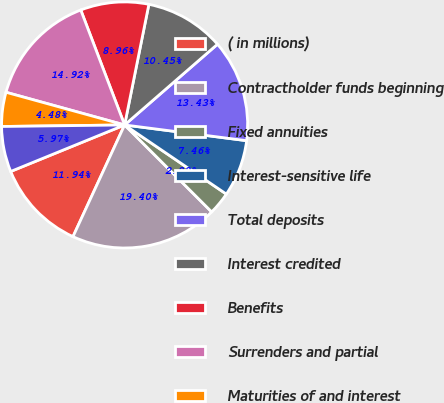Convert chart to OTSL. <chart><loc_0><loc_0><loc_500><loc_500><pie_chart><fcel>( in millions)<fcel>Contractholder funds beginning<fcel>Fixed annuities<fcel>Interest-sensitive life<fcel>Total deposits<fcel>Interest credited<fcel>Benefits<fcel>Surrenders and partial<fcel>Maturities of and interest<fcel>Contract charges<nl><fcel>11.94%<fcel>19.4%<fcel>2.99%<fcel>7.46%<fcel>13.43%<fcel>10.45%<fcel>8.96%<fcel>14.92%<fcel>4.48%<fcel>5.97%<nl></chart> 